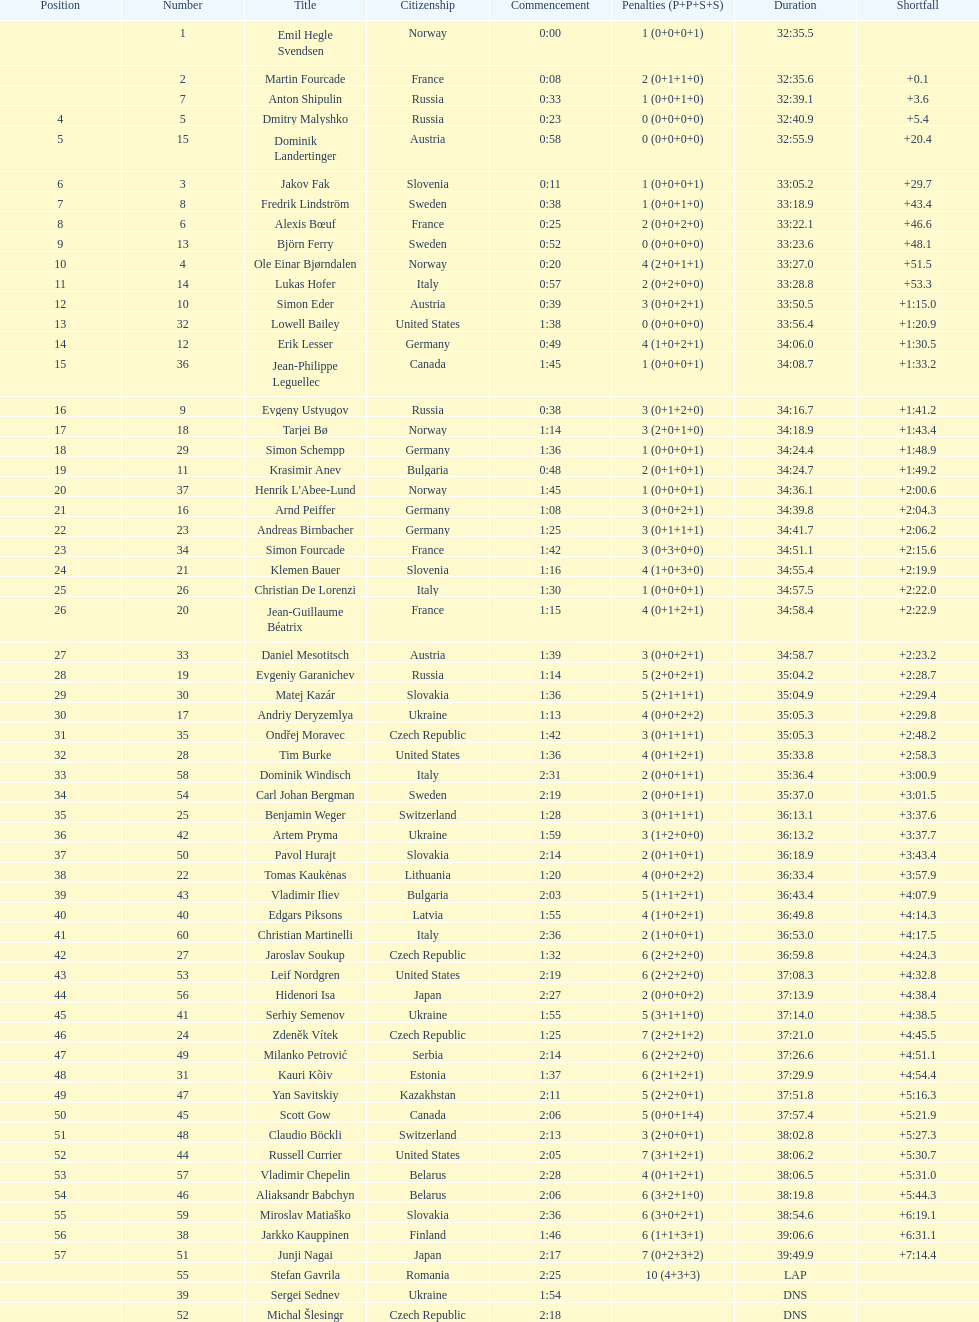Who is the highest-ranked runner from sweden? Fredrik Lindström. 